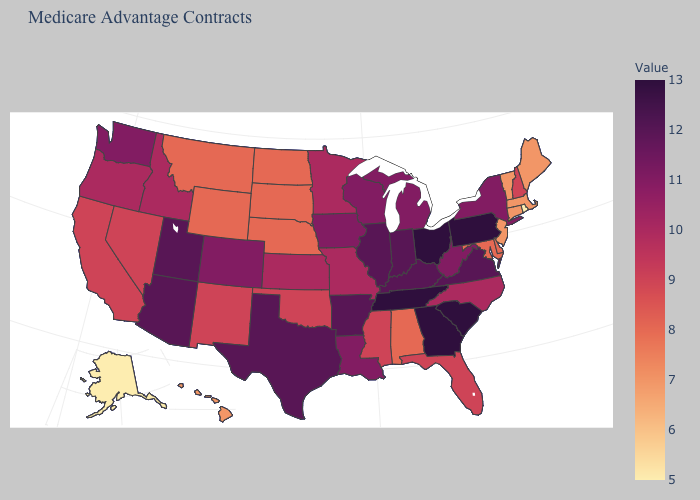Does the map have missing data?
Quick response, please. No. Does Missouri have the lowest value in the MidWest?
Answer briefly. No. Among the states that border California , does Arizona have the highest value?
Write a very short answer. Yes. Which states hav the highest value in the MidWest?
Write a very short answer. Ohio. 